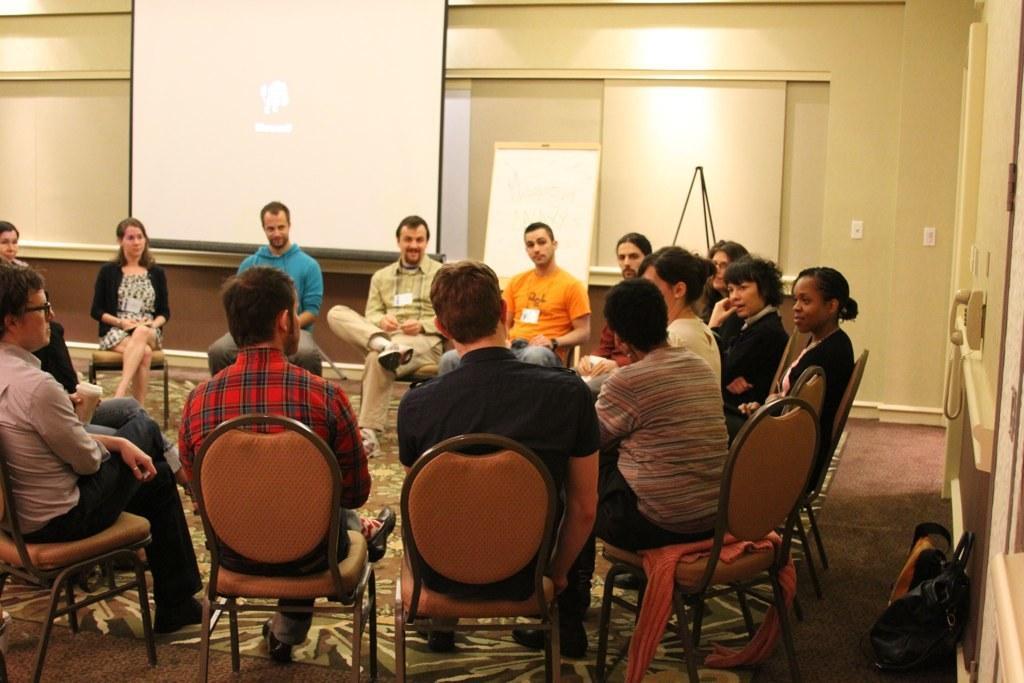Please provide a concise description of this image. There is a group of people. They are sitting on a chairs. Some persons are smiling. Some persons are wearing a id cards. On the left side of the person is wearing a spectacle. We can see in the background projector,wall,board,socket and telephone. 